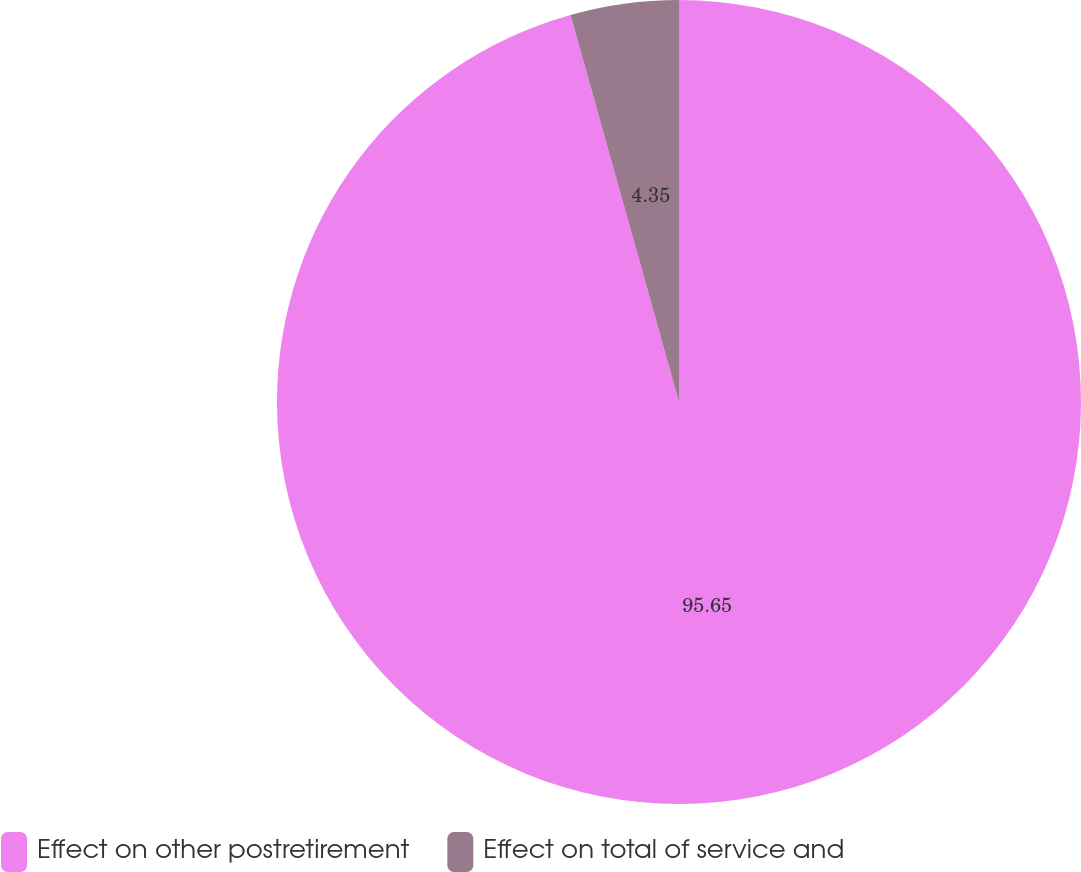Convert chart. <chart><loc_0><loc_0><loc_500><loc_500><pie_chart><fcel>Effect on other postretirement<fcel>Effect on total of service and<nl><fcel>95.65%<fcel>4.35%<nl></chart> 